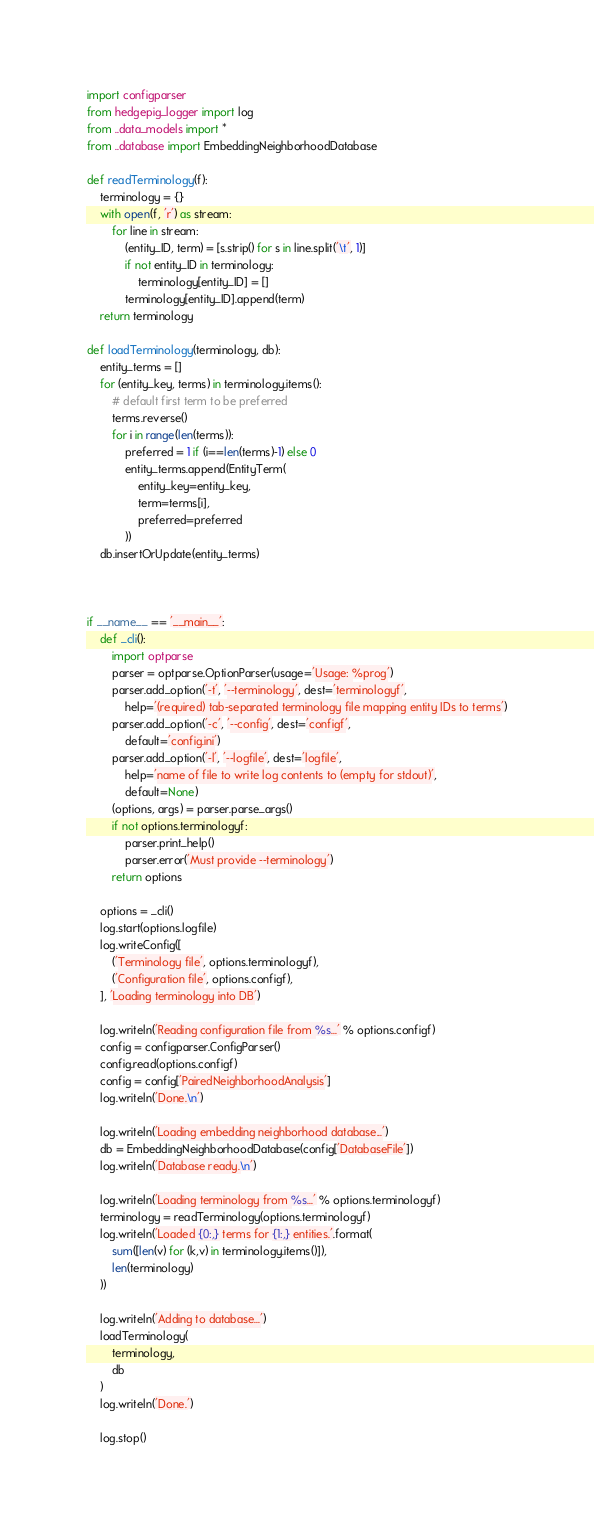Convert code to text. <code><loc_0><loc_0><loc_500><loc_500><_Python_>import configparser
from hedgepig_logger import log
from ..data_models import *
from ..database import EmbeddingNeighborhoodDatabase

def readTerminology(f):
    terminology = {}
    with open(f, 'r') as stream:
        for line in stream:
            (entity_ID, term) = [s.strip() for s in line.split('\t', 1)]
            if not entity_ID in terminology:
                terminology[entity_ID] = []
            terminology[entity_ID].append(term)
    return terminology

def loadTerminology(terminology, db):
    entity_terms = []
    for (entity_key, terms) in terminology.items():
        # default first term to be preferred
        terms.reverse()
        for i in range(len(terms)):
            preferred = 1 if (i==len(terms)-1) else 0
            entity_terms.append(EntityTerm(
                entity_key=entity_key,
                term=terms[i],
                preferred=preferred
            ))
    db.insertOrUpdate(entity_terms)



if __name__ == '__main__':
    def _cli():
        import optparse
        parser = optparse.OptionParser(usage='Usage: %prog')
        parser.add_option('-t', '--terminology', dest='terminologyf',
            help='(required) tab-separated terminology file mapping entity IDs to terms')
        parser.add_option('-c', '--config', dest='configf',
            default='config.ini')
        parser.add_option('-l', '--logfile', dest='logfile',
            help='name of file to write log contents to (empty for stdout)',
            default=None)
        (options, args) = parser.parse_args()
        if not options.terminologyf:
            parser.print_help()
            parser.error('Must provide --terminology')
        return options

    options = _cli()
    log.start(options.logfile)
    log.writeConfig([
        ('Terminology file', options.terminologyf),
        ('Configuration file', options.configf),
    ], 'Loading terminology into DB')

    log.writeln('Reading configuration file from %s...' % options.configf)
    config = configparser.ConfigParser()
    config.read(options.configf)
    config = config['PairedNeighborhoodAnalysis']
    log.writeln('Done.\n')

    log.writeln('Loading embedding neighborhood database...')
    db = EmbeddingNeighborhoodDatabase(config['DatabaseFile'])
    log.writeln('Database ready.\n')

    log.writeln('Loading terminology from %s...' % options.terminologyf)
    terminology = readTerminology(options.terminologyf)
    log.writeln('Loaded {0:,} terms for {1:,} entities.'.format(
        sum([len(v) for (k,v) in terminology.items()]),
        len(terminology)
    ))

    log.writeln('Adding to database...')
    loadTerminology(
        terminology,
        db
    )
    log.writeln('Done.')

    log.stop()
</code> 